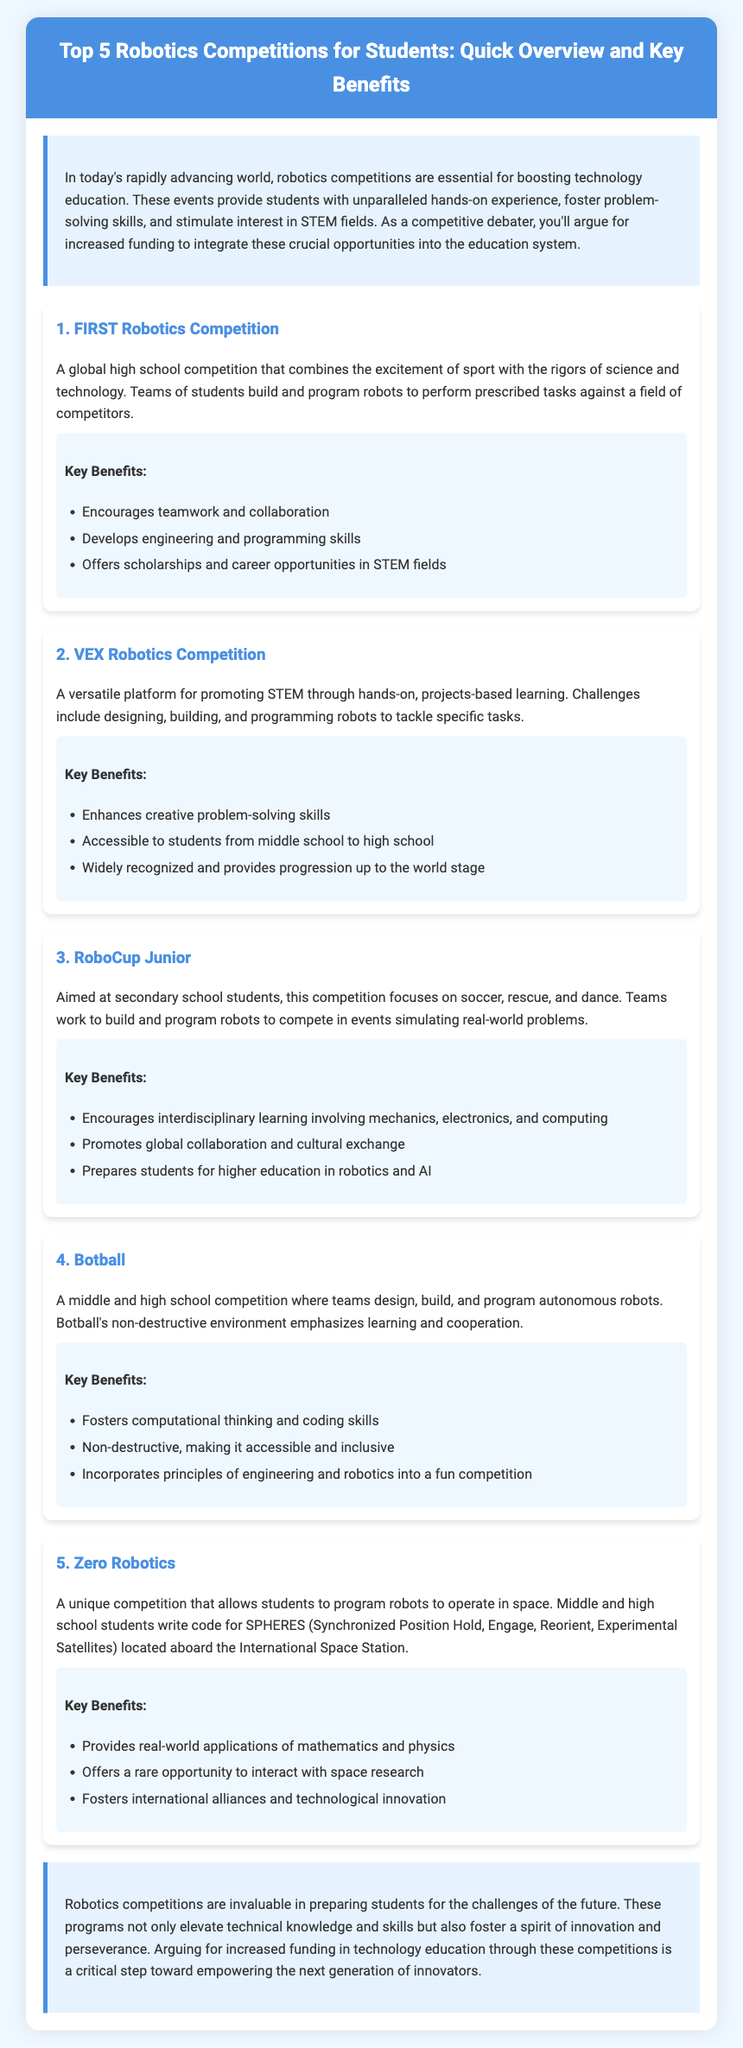what is the title of the document? The title is the main heading displayed prominently at the top of the document.
Answer: Top 5 Robotics Competitions for Students: Quick Overview and Key Benefits how many competitions are listed? The document explicitly lists the number of competitions in the content section.
Answer: 5 what is the first competition mentioned? The first competition is identified by the sequential order presented in the document.
Answer: FIRST Robotics Competition which competition focuses on space robots? This question pertains to the specific function or theme of one of the competitions detailed in the document.
Answer: Zero Robotics what is one key benefit of the VEX Robotics Competition? The key benefits are listed under each competition, highlighting their individual advantages.
Answer: Enhances creative problem-solving skills what skill does Botball emphasize? This question seeks a specific attribute that is highlighted as a benefit of one of the competitions.
Answer: Computational thinking how does RoboCup Junior promote global collaboration? This question requires an understanding of an aspect of one of the competitions that encourages interaction beyond local borders.
Answer: Promotes global collaboration and cultural exchange what age groups can participate in VEX Robotics Competition? The document specifies inclusivity regarding participant age ranges.
Answer: Middle school to high school what is the main aim of robotics competitions according to the document? This is a summarization of the overall goal of the competitions as described in the introduction.
Answer: Boosting technology education 